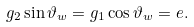<formula> <loc_0><loc_0><loc_500><loc_500>g _ { 2 } \sin \vartheta _ { w } = g _ { 1 } \cos \vartheta _ { w } = e .</formula> 